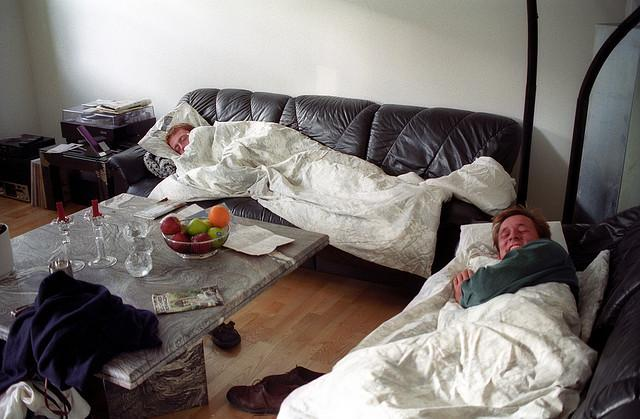What is the bowl holding the fruit made from? Please explain your reasoning. glass. A clear bowl with fruit in it is on a table. glass is clear. 